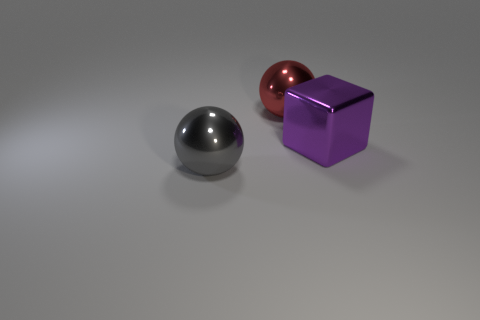Does the metallic thing behind the metal block have the same size as the large purple metal cube?
Give a very brief answer. Yes. Is there any other thing that has the same size as the purple object?
Offer a terse response. Yes. What is the size of the gray thing that is the same shape as the large red object?
Your response must be concise. Large. Are there the same number of big red metal spheres that are in front of the red sphere and big metal cubes to the left of the big purple cube?
Your answer should be compact. Yes. How big is the shiny object behind the large metal block?
Ensure brevity in your answer.  Large. Are there any other things that are the same shape as the red object?
Offer a very short reply. Yes. Are there an equal number of large purple objects in front of the big block and red objects?
Your answer should be very brief. No. There is a purple metal block; are there any big spheres to the left of it?
Your answer should be very brief. Yes. There is a red thing; is its shape the same as the thing left of the red metallic object?
Offer a very short reply. Yes. What color is the big block that is the same material as the big gray object?
Make the answer very short. Purple. 